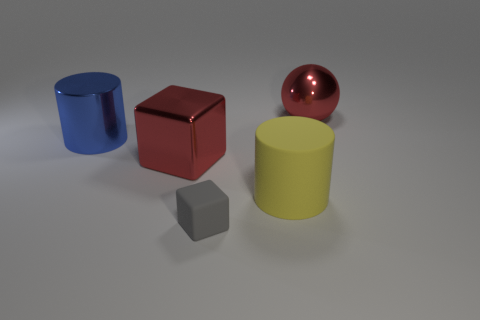Is there any other thing that is the same size as the gray thing?
Give a very brief answer. No. What number of things are cubes that are behind the tiny matte cube or big things behind the big yellow object?
Provide a succinct answer. 3. What number of things are the same color as the big cube?
Make the answer very short. 1. What is the color of the big metallic object that is the same shape as the tiny gray thing?
Ensure brevity in your answer.  Red. What shape is the large thing that is in front of the large blue object and behind the yellow rubber cylinder?
Your response must be concise. Cube. Are there more blue metal things than small cyan cubes?
Keep it short and to the point. Yes. What is the material of the red ball?
Make the answer very short. Metal. There is another thing that is the same shape as the tiny rubber object; what size is it?
Your response must be concise. Large. Are there any big blue shiny objects behind the metal object to the left of the big block?
Your response must be concise. No. Is the color of the tiny block the same as the ball?
Your response must be concise. No. 